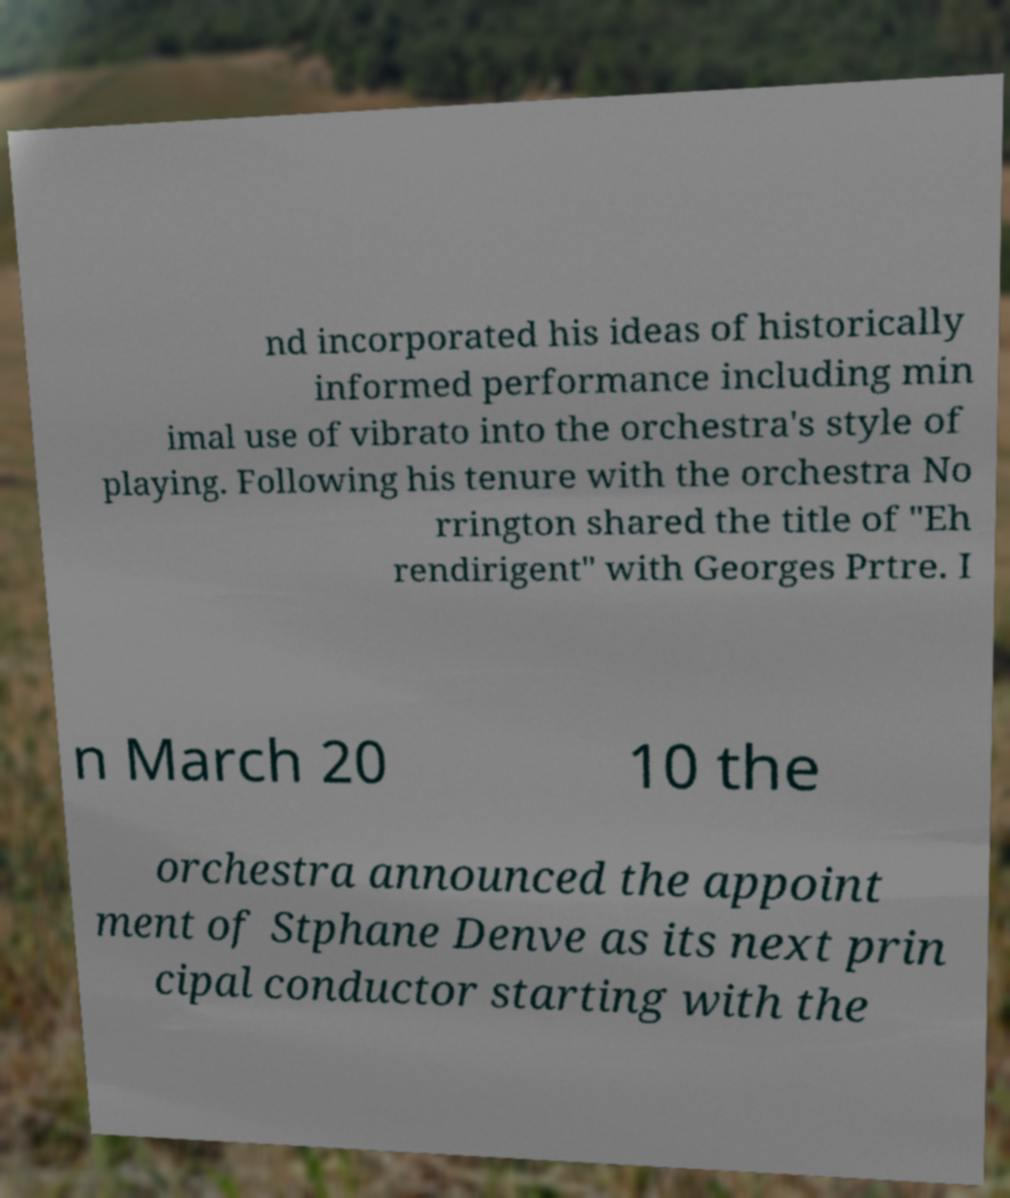Could you extract and type out the text from this image? nd incorporated his ideas of historically informed performance including min imal use of vibrato into the orchestra's style of playing. Following his tenure with the orchestra No rrington shared the title of "Eh rendirigent" with Georges Prtre. I n March 20 10 the orchestra announced the appoint ment of Stphane Denve as its next prin cipal conductor starting with the 